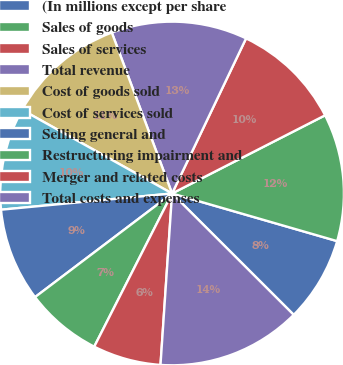<chart> <loc_0><loc_0><loc_500><loc_500><pie_chart><fcel>(In millions except per share<fcel>Sales of goods<fcel>Sales of services<fcel>Total revenue<fcel>Cost of goods sold<fcel>Cost of services sold<fcel>Selling general and<fcel>Restructuring impairment and<fcel>Merger and related costs<fcel>Total costs and expenses<nl><fcel>8.01%<fcel>11.99%<fcel>10.4%<fcel>12.79%<fcel>11.2%<fcel>9.6%<fcel>8.8%<fcel>7.21%<fcel>6.41%<fcel>13.59%<nl></chart> 